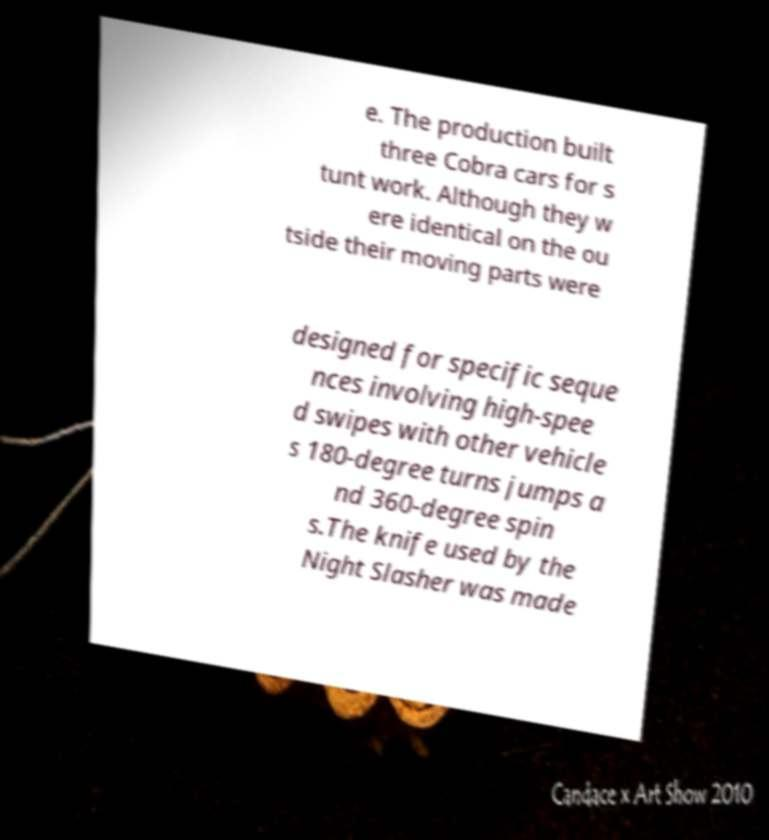There's text embedded in this image that I need extracted. Can you transcribe it verbatim? e. The production built three Cobra cars for s tunt work. Although they w ere identical on the ou tside their moving parts were designed for specific seque nces involving high-spee d swipes with other vehicle s 180-degree turns jumps a nd 360-degree spin s.The knife used by the Night Slasher was made 